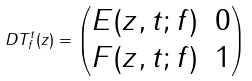Convert formula to latex. <formula><loc_0><loc_0><loc_500><loc_500>D T _ { f } ^ { t } ( z ) = \begin{pmatrix} E ( z , t ; f ) & 0 \\ F ( z , t ; f ) & 1 \end{pmatrix}</formula> 